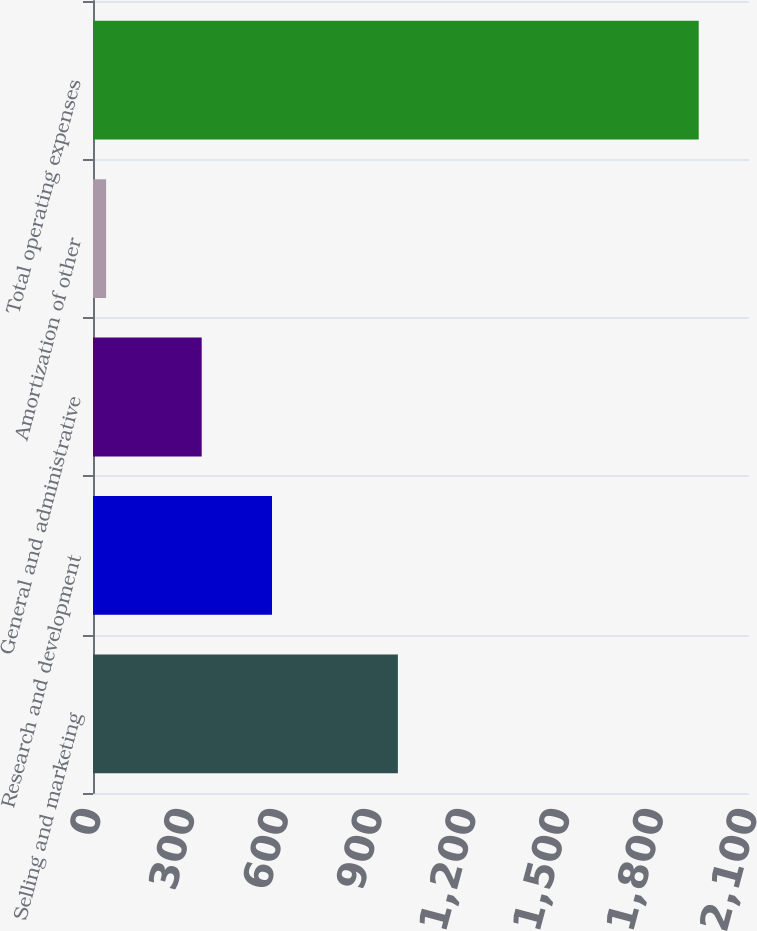Convert chart. <chart><loc_0><loc_0><loc_500><loc_500><bar_chart><fcel>Selling and marketing<fcel>Research and development<fcel>General and administrative<fcel>Amortization of other<fcel>Total operating expenses<nl><fcel>976<fcel>573<fcel>348<fcel>42<fcel>1939<nl></chart> 